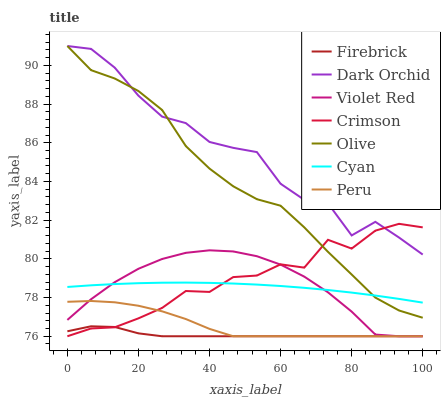Does Firebrick have the minimum area under the curve?
Answer yes or no. Yes. Does Dark Orchid have the maximum area under the curve?
Answer yes or no. Yes. Does Dark Orchid have the minimum area under the curve?
Answer yes or no. No. Does Firebrick have the maximum area under the curve?
Answer yes or no. No. Is Cyan the smoothest?
Answer yes or no. Yes. Is Dark Orchid the roughest?
Answer yes or no. Yes. Is Firebrick the smoothest?
Answer yes or no. No. Is Firebrick the roughest?
Answer yes or no. No. Does Violet Red have the lowest value?
Answer yes or no. Yes. Does Dark Orchid have the lowest value?
Answer yes or no. No. Does Olive have the highest value?
Answer yes or no. Yes. Does Firebrick have the highest value?
Answer yes or no. No. Is Firebrick less than Cyan?
Answer yes or no. Yes. Is Cyan greater than Peru?
Answer yes or no. Yes. Does Firebrick intersect Peru?
Answer yes or no. Yes. Is Firebrick less than Peru?
Answer yes or no. No. Is Firebrick greater than Peru?
Answer yes or no. No. Does Firebrick intersect Cyan?
Answer yes or no. No. 